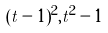<formula> <loc_0><loc_0><loc_500><loc_500>( t - 1 ) ^ { 2 } , t ^ { 2 } - 1</formula> 